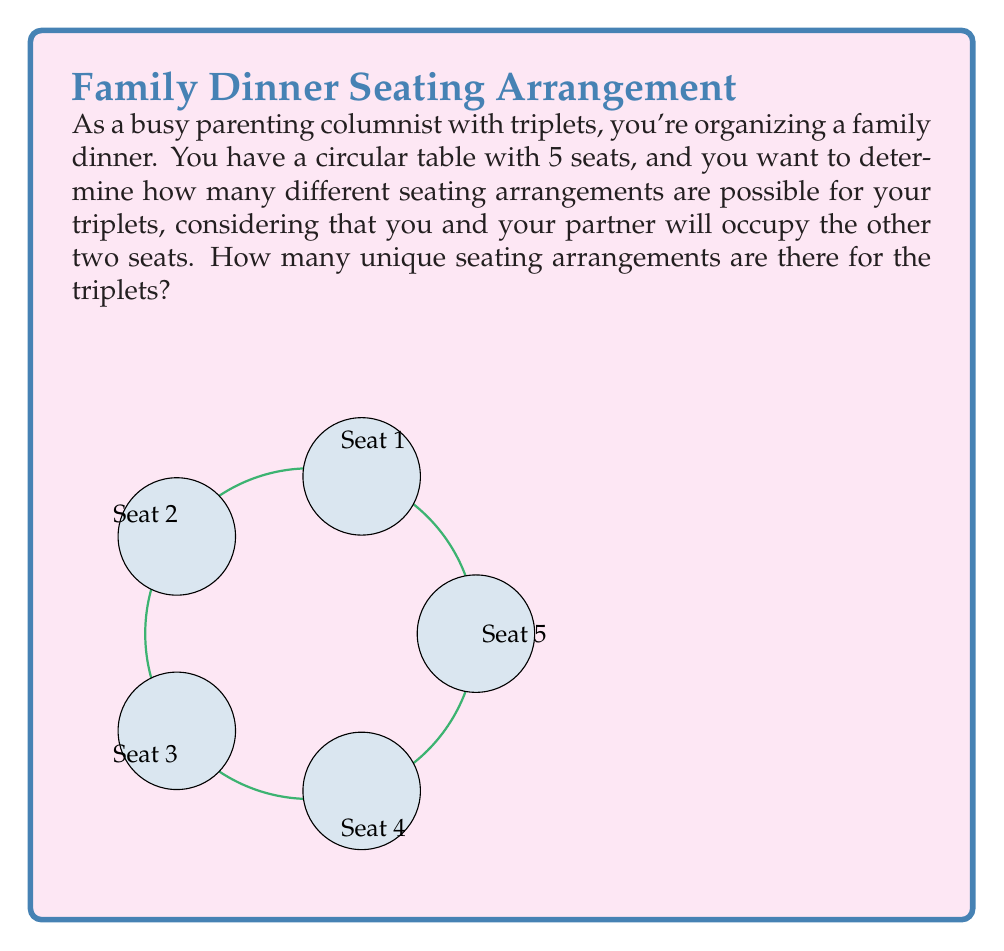Solve this math problem. Let's approach this step-by-step:

1) First, we need to understand that in a circular arrangement, rotations of the same arrangement are considered identical. This means we can fix the position of one person (e.g., you or your partner) and arrange the others relative to this fixed position.

2) Let's fix your position at Seat 1. Your partner can sit in any of the remaining 4 seats.

3) Once you and your partner are seated, we need to arrange the triplets in the remaining 3 seats.

4) This becomes a problem of permutations. We have 3 distinct children to arrange in 3 distinct seats.

5) The number of permutations of n distinct objects is given by $n!$.

6) In this case, $n = 3$, so we have $3! = 3 \times 2 \times 1 = 6$ possible arrangements of the triplets.

7) However, we need to consider that your partner can sit in 4 different seats, and for each of these, we have 6 arrangements of the triplets.

8) Therefore, the total number of unique seating arrangements is:

   $$ 4 \times 6 = 24 $$

Thus, there are 24 possible seating arrangements for your triplets at the dinner table.
Answer: 24 